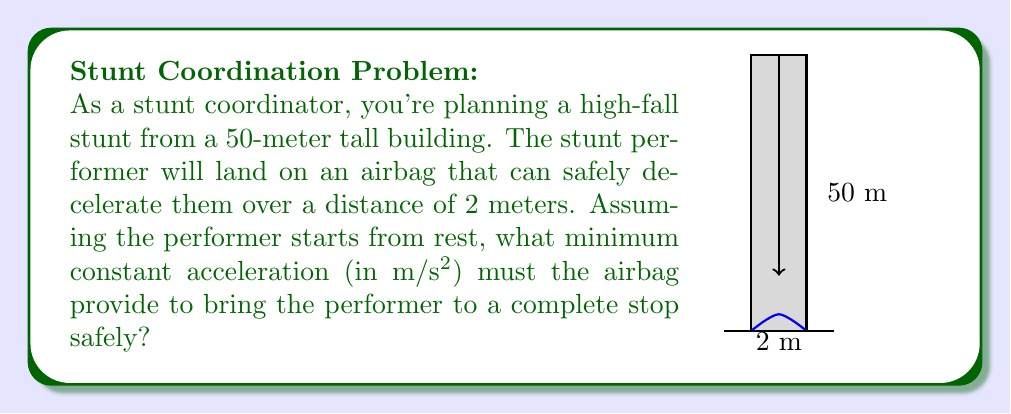Provide a solution to this math problem. Let's approach this step-by-step using the equations of motion:

1) First, we need to find the velocity of the performer just before hitting the airbag. We can use the equation:

   $$v^2 = u^2 + 2as$$

   Where $v$ is final velocity, $u$ is initial velocity (0 m/s), $a$ is acceleration due to gravity (9.8 m/s²), and $s$ is displacement (50 m).

2) Substituting these values:

   $$v^2 = 0^2 + 2(9.8)(50)$$
   $$v^2 = 980$$
   $$v = \sqrt{980} \approx 31.3 \text{ m/s}$$

3) Now, we need to find the acceleration required to stop the performer over 2 meters. We can use the same equation, but now $v$ is 0 (final stopped state), $u$ is 31.3 m/s, $s$ is -2 m (negative because it's in the opposite direction to the initial motion), and we're solving for $a$.

4) Rearranging the equation:

   $$0^2 = 31.3^2 + 2a(-2)$$
   $$0 = 979.69 - 4a$$
   $$4a = 979.69$$
   $$a = 244.92 \text{ m/s²}$$

5) This acceleration is negative because it's in the opposite direction to the initial motion, so we take the absolute value for our final answer.
Answer: 244.92 m/s² 